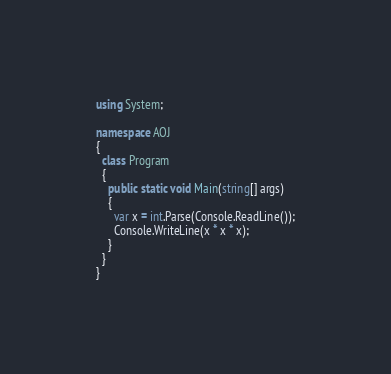Convert code to text. <code><loc_0><loc_0><loc_500><loc_500><_C#_>using System;

namespace AOJ
{
  class Program
  {
    public static void Main(string[] args)
    {
      var x = int.Parse(Console.ReadLine());
      Console.WriteLine(x * x * x);
    }
  }
}</code> 